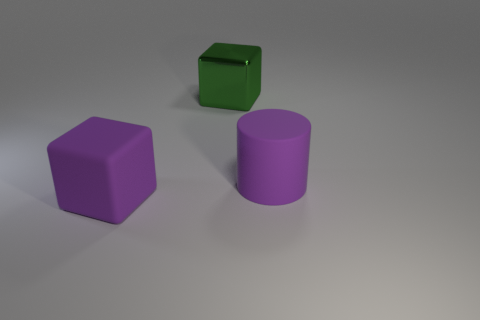Add 2 small red metal cubes. How many objects exist? 5 Subtract all cylinders. How many objects are left? 2 Subtract all large brown cylinders. Subtract all big purple things. How many objects are left? 1 Add 1 big cylinders. How many big cylinders are left? 2 Add 1 big blocks. How many big blocks exist? 3 Subtract 0 yellow cylinders. How many objects are left? 3 